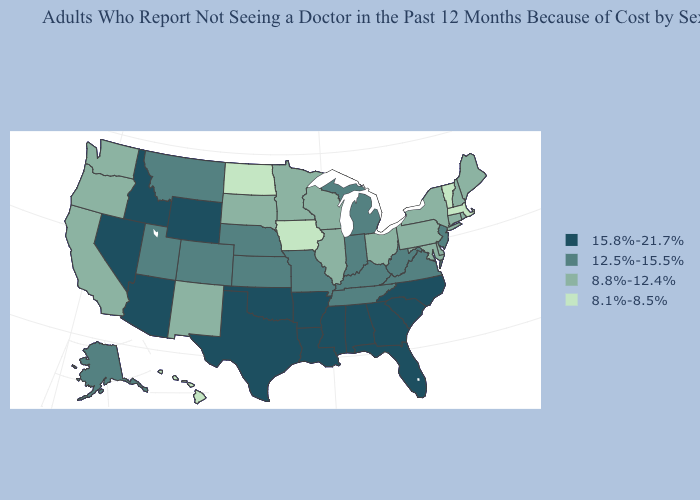Which states have the lowest value in the West?
Write a very short answer. Hawaii. Name the states that have a value in the range 12.5%-15.5%?
Quick response, please. Alaska, Colorado, Indiana, Kansas, Kentucky, Michigan, Missouri, Montana, Nebraska, New Jersey, Tennessee, Utah, Virginia, West Virginia. Does Wisconsin have the same value as Washington?
Write a very short answer. Yes. Is the legend a continuous bar?
Be succinct. No. Does Georgia have a lower value than Michigan?
Write a very short answer. No. Which states have the lowest value in the USA?
Answer briefly. Hawaii, Iowa, Massachusetts, North Dakota, Vermont. Among the states that border Idaho , does Oregon have the lowest value?
Short answer required. Yes. What is the lowest value in the USA?
Answer briefly. 8.1%-8.5%. Among the states that border California , does Nevada have the lowest value?
Write a very short answer. No. What is the highest value in states that border West Virginia?
Be succinct. 12.5%-15.5%. What is the value of South Dakota?
Give a very brief answer. 8.8%-12.4%. Among the states that border North Dakota , does Montana have the lowest value?
Short answer required. No. Which states have the lowest value in the USA?
Give a very brief answer. Hawaii, Iowa, Massachusetts, North Dakota, Vermont. Does Idaho have the highest value in the West?
Write a very short answer. Yes. 